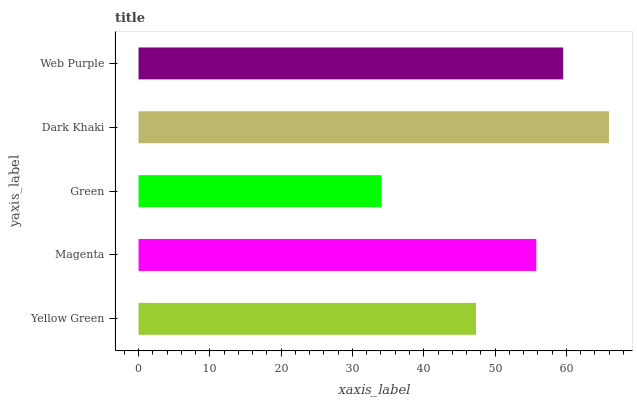Is Green the minimum?
Answer yes or no. Yes. Is Dark Khaki the maximum?
Answer yes or no. Yes. Is Magenta the minimum?
Answer yes or no. No. Is Magenta the maximum?
Answer yes or no. No. Is Magenta greater than Yellow Green?
Answer yes or no. Yes. Is Yellow Green less than Magenta?
Answer yes or no. Yes. Is Yellow Green greater than Magenta?
Answer yes or no. No. Is Magenta less than Yellow Green?
Answer yes or no. No. Is Magenta the high median?
Answer yes or no. Yes. Is Magenta the low median?
Answer yes or no. Yes. Is Green the high median?
Answer yes or no. No. Is Dark Khaki the low median?
Answer yes or no. No. 